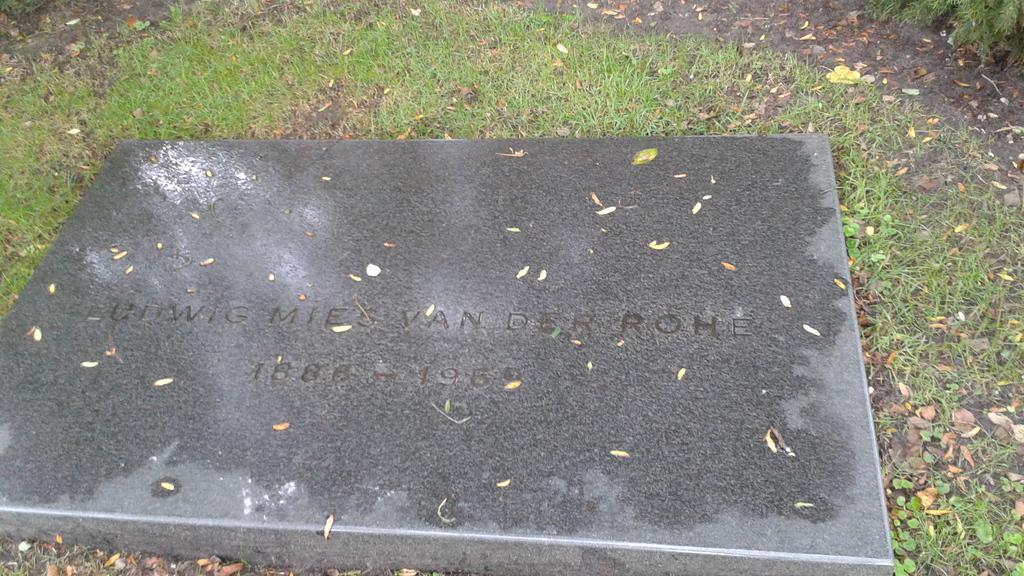Describe this image in one or two sentences. In this picture we can see dry leaves, grass and a gravestone. At the bottom we can see soil. At the top there is soil. 